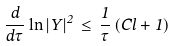Convert formula to latex. <formula><loc_0><loc_0><loc_500><loc_500>\frac { d } { d \tau } \ln | Y | ^ { 2 } \, \leq \, \frac { 1 } { \tau } \, ( C l + 1 )</formula> 